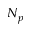<formula> <loc_0><loc_0><loc_500><loc_500>N _ { p }</formula> 